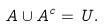Convert formula to latex. <formula><loc_0><loc_0><loc_500><loc_500>A \cup A ^ { c } = U .</formula> 